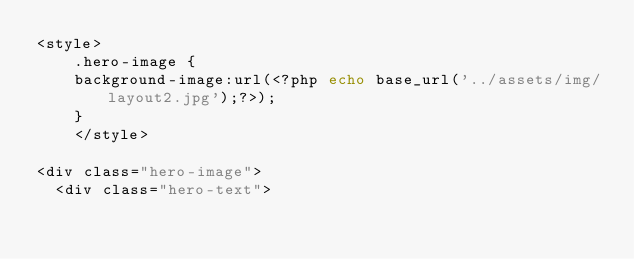<code> <loc_0><loc_0><loc_500><loc_500><_PHP_><style>
    .hero-image {
    background-image:url(<?php echo base_url('../assets/img/layout2.jpg');?>);
    }
    </style>

<div class="hero-image">
  <div class="hero-text"></code> 